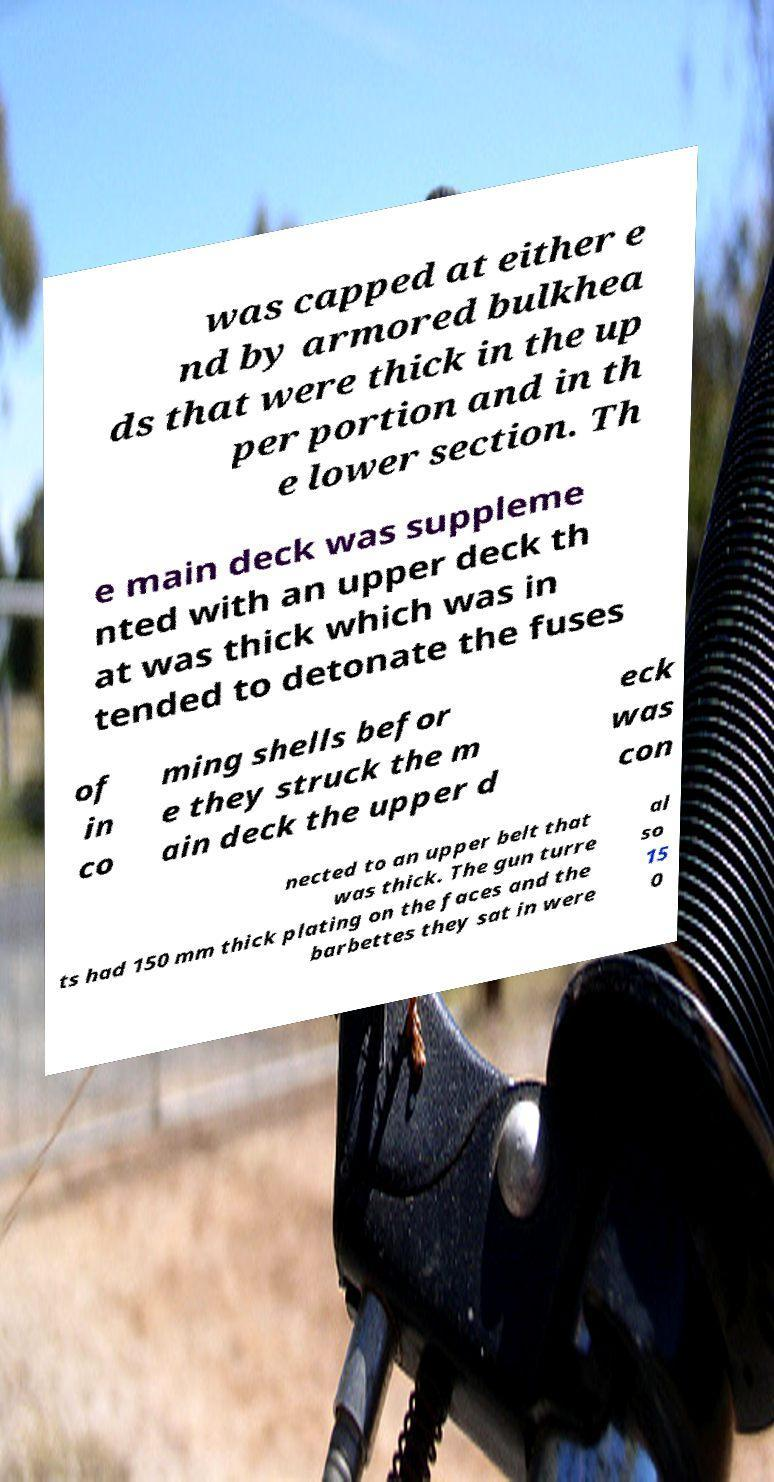Can you accurately transcribe the text from the provided image for me? was capped at either e nd by armored bulkhea ds that were thick in the up per portion and in th e lower section. Th e main deck was suppleme nted with an upper deck th at was thick which was in tended to detonate the fuses of in co ming shells befor e they struck the m ain deck the upper d eck was con nected to an upper belt that was thick. The gun turre ts had 150 mm thick plating on the faces and the barbettes they sat in were al so 15 0 